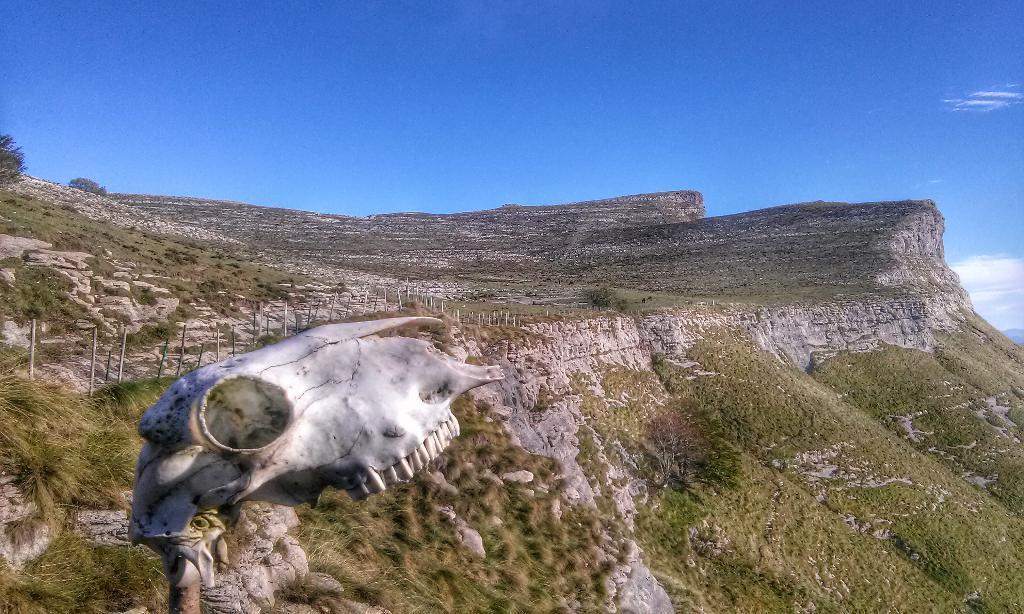Please provide a concise description of this image. There is a hill with some greenery and there is a sculpture beside the hill and there is some fencing beside the sculpture. 